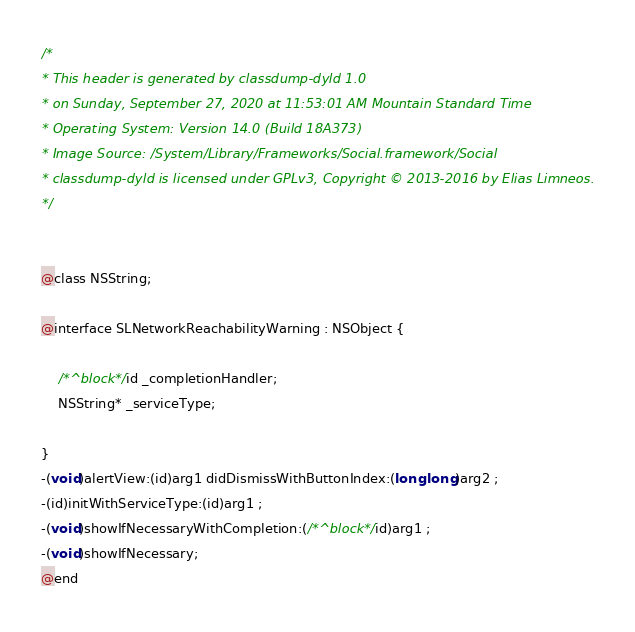Convert code to text. <code><loc_0><loc_0><loc_500><loc_500><_C_>/*
* This header is generated by classdump-dyld 1.0
* on Sunday, September 27, 2020 at 11:53:01 AM Mountain Standard Time
* Operating System: Version 14.0 (Build 18A373)
* Image Source: /System/Library/Frameworks/Social.framework/Social
* classdump-dyld is licensed under GPLv3, Copyright © 2013-2016 by Elias Limneos.
*/


@class NSString;

@interface SLNetworkReachabilityWarning : NSObject {

	/*^block*/id _completionHandler;
	NSString* _serviceType;

}
-(void)alertView:(id)arg1 didDismissWithButtonIndex:(long long)arg2 ;
-(id)initWithServiceType:(id)arg1 ;
-(void)showIfNecessaryWithCompletion:(/*^block*/id)arg1 ;
-(void)showIfNecessary;
@end

</code> 